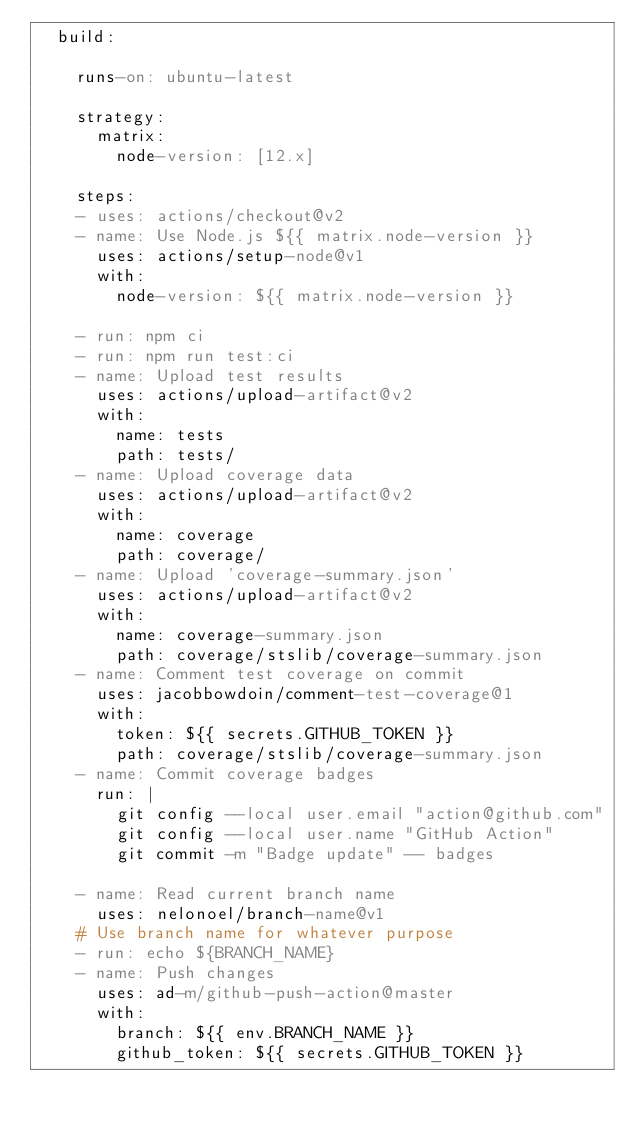Convert code to text. <code><loc_0><loc_0><loc_500><loc_500><_YAML_>  build:

    runs-on: ubuntu-latest

    strategy:
      matrix:
        node-version: [12.x]

    steps:
    - uses: actions/checkout@v2
    - name: Use Node.js ${{ matrix.node-version }}
      uses: actions/setup-node@v1
      with:
        node-version: ${{ matrix.node-version }}

    - run: npm ci
    - run: npm run test:ci
    - name: Upload test results
      uses: actions/upload-artifact@v2
      with:
        name: tests
        path: tests/
    - name: Upload coverage data
      uses: actions/upload-artifact@v2
      with:
        name: coverage
        path: coverage/
    - name: Upload 'coverage-summary.json'
      uses: actions/upload-artifact@v2
      with:
        name: coverage-summary.json
        path: coverage/stslib/coverage-summary.json
    - name: Comment test coverage on commit
      uses: jacobbowdoin/comment-test-coverage@1
      with:
        token: ${{ secrets.GITHUB_TOKEN }}
        path: coverage/stslib/coverage-summary.json
    - name: Commit coverage badges
      run: |
        git config --local user.email "action@github.com"
        git config --local user.name "GitHub Action"
        git commit -m "Badge update" -- badges

    - name: Read current branch name
      uses: nelonoel/branch-name@v1
    # Use branch name for whatever purpose
    - run: echo ${BRANCH_NAME}
    - name: Push changes
      uses: ad-m/github-push-action@master
      with:
        branch: ${{ env.BRANCH_NAME }}
        github_token: ${{ secrets.GITHUB_TOKEN }}
</code> 